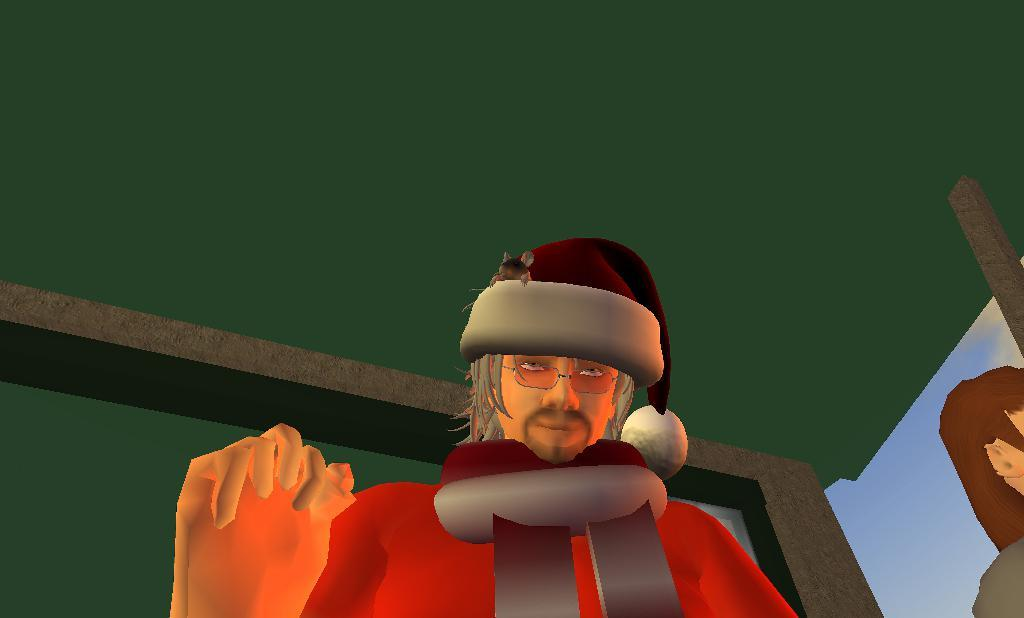What type of image is being described? The image is an animated picture. Can you describe the person in the image? The person in the image is wearing a Santa cap. What is unique about the Santa cap? The Santa cap has a mouse on it. What is the background color of the image? The background color is green. What type of request does the bat make in the image? There is no bat present in the image, so it is not possible to answer that question. 